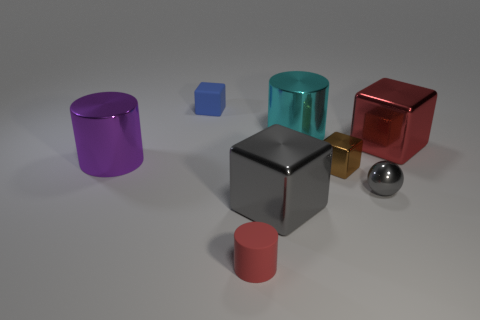What shape is the red thing that is left of the large metallic cylinder that is to the right of the blue block?
Give a very brief answer. Cylinder. What number of other things are made of the same material as the brown object?
Provide a short and direct response. 5. Are the cyan thing and the tiny block that is right of the matte block made of the same material?
Your response must be concise. Yes. How many objects are gray things that are to the right of the big cyan metal cylinder or large metallic things right of the blue thing?
Your answer should be very brief. 4. What number of other things are there of the same color as the sphere?
Give a very brief answer. 1. Is the number of tiny gray balls behind the matte cube greater than the number of tiny metallic things that are to the right of the tiny brown thing?
Offer a very short reply. No. What number of cylinders are gray things or large purple things?
Offer a very short reply. 1. How many things are tiny things that are to the right of the rubber block or gray shiny spheres?
Provide a short and direct response. 3. What shape is the shiny thing that is right of the gray metallic object behind the gray metal object that is in front of the tiny gray sphere?
Give a very brief answer. Cube. What number of other large metallic objects have the same shape as the big purple object?
Keep it short and to the point. 1. 